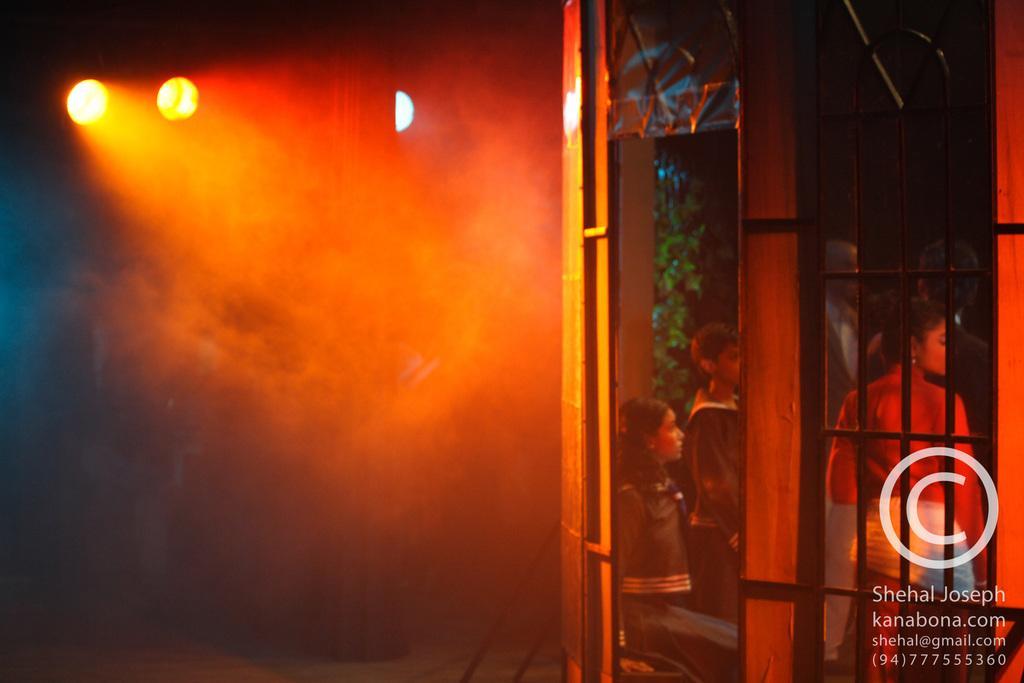Can you describe this image briefly? In the image there are lights on the left side, on the right side there is a glass wall with few people standing behind it. 